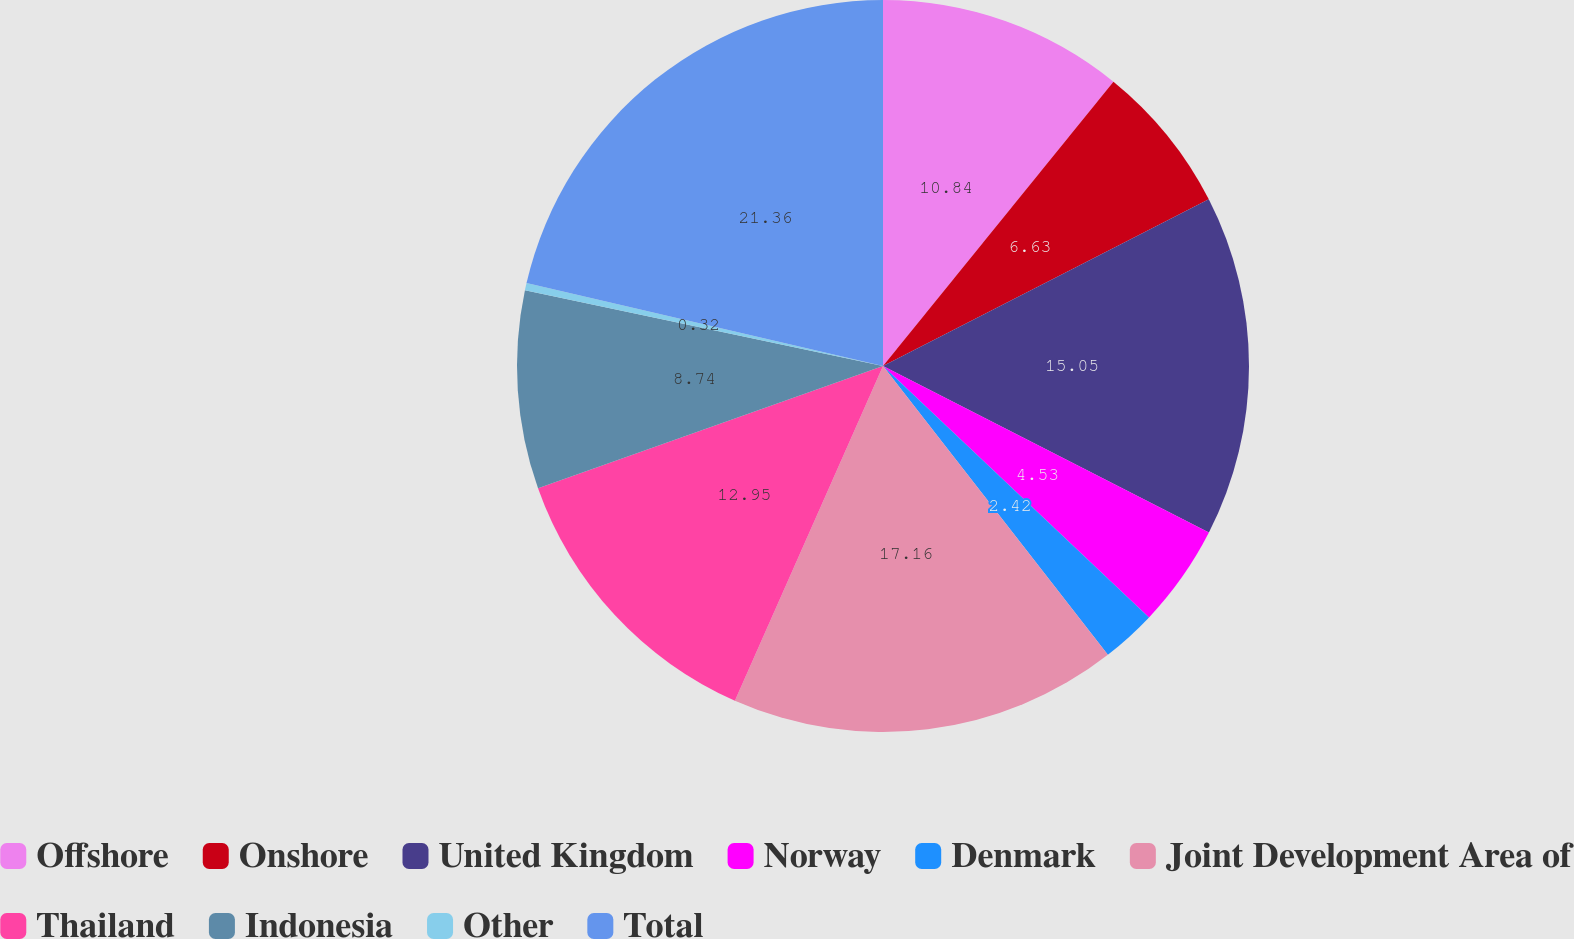Convert chart. <chart><loc_0><loc_0><loc_500><loc_500><pie_chart><fcel>Offshore<fcel>Onshore<fcel>United Kingdom<fcel>Norway<fcel>Denmark<fcel>Joint Development Area of<fcel>Thailand<fcel>Indonesia<fcel>Other<fcel>Total<nl><fcel>10.84%<fcel>6.63%<fcel>15.05%<fcel>4.53%<fcel>2.42%<fcel>17.16%<fcel>12.95%<fcel>8.74%<fcel>0.32%<fcel>21.36%<nl></chart> 